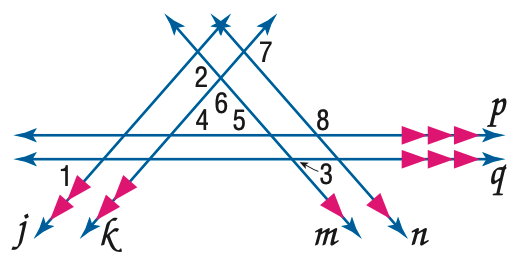Answer the mathemtical geometry problem and directly provide the correct option letter.
Question: In the figure, m \angle 1 = 50 and m \angle 3 = 60. Find the measure of \angle 5.
Choices: A: 50 B: 60 C: 70 D: 80 B 